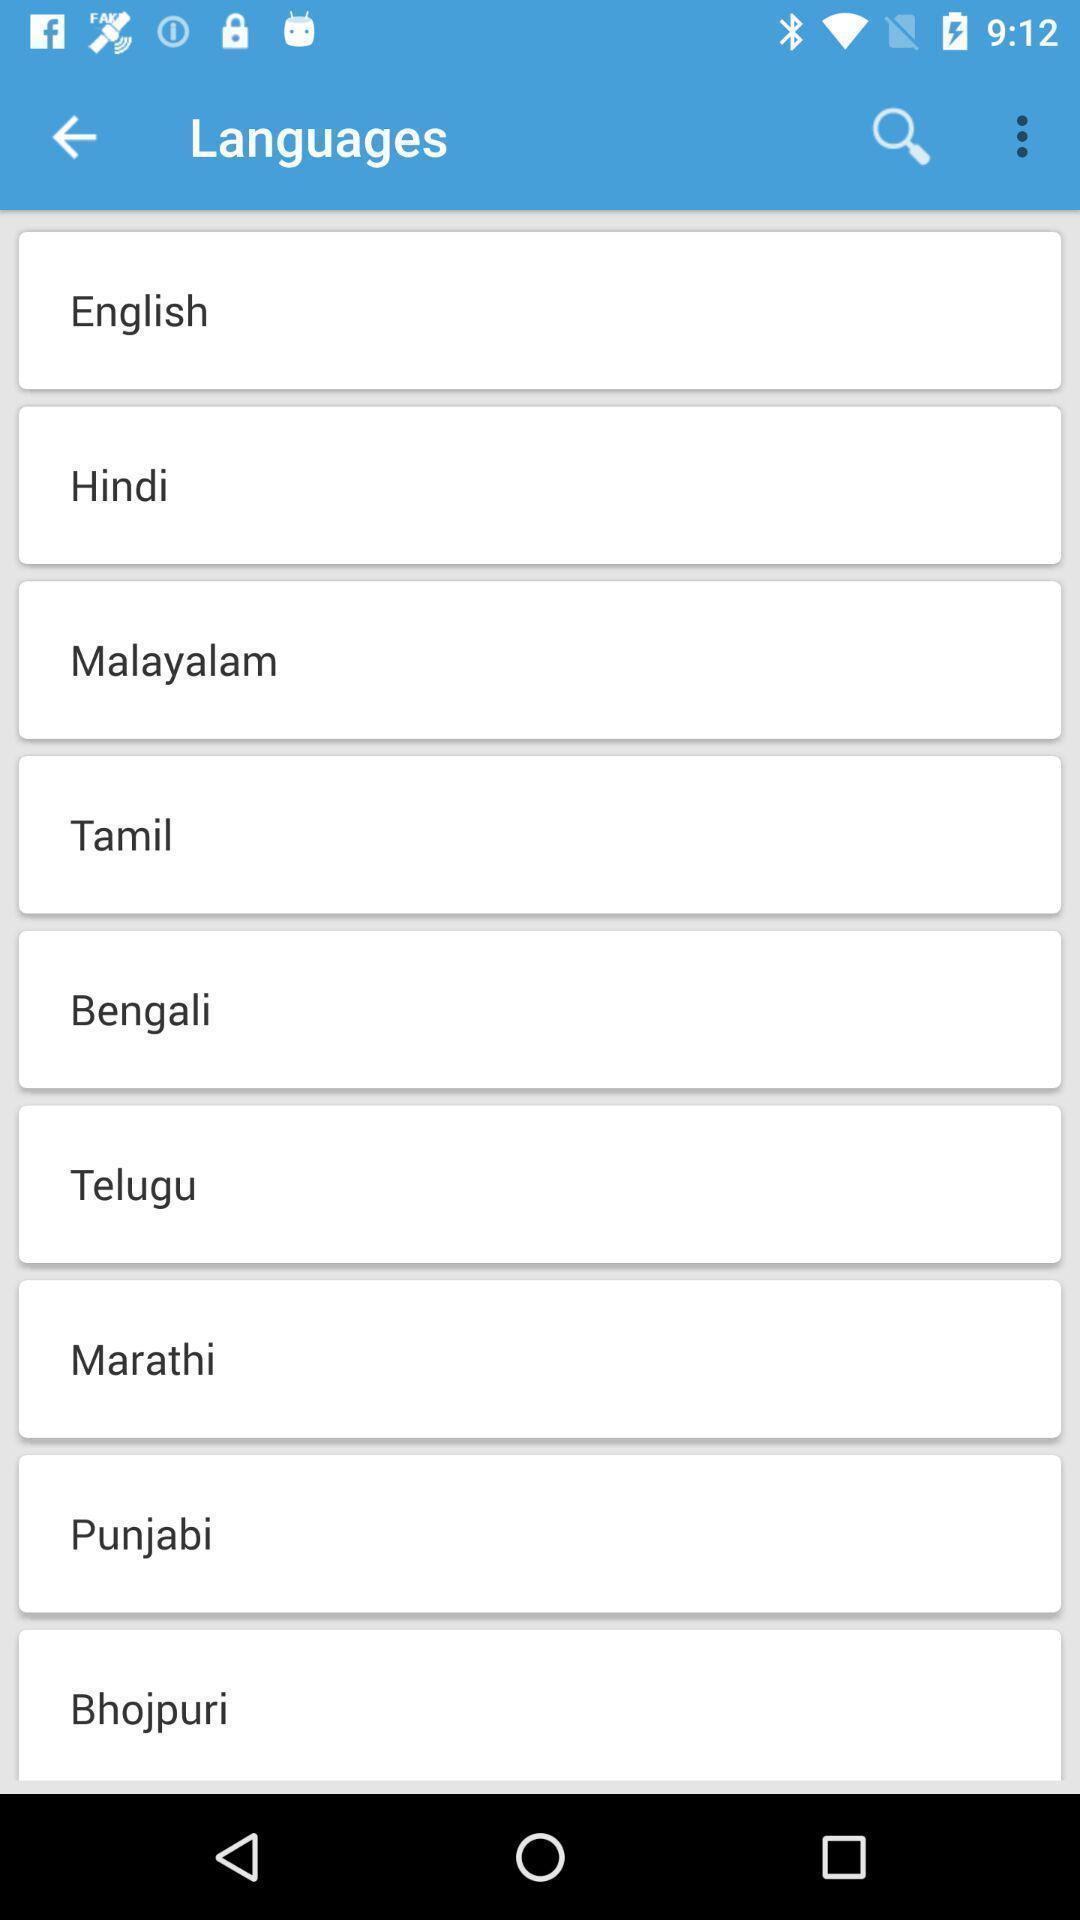Summarize the information in this screenshot. Page showing list of languages with search option. 